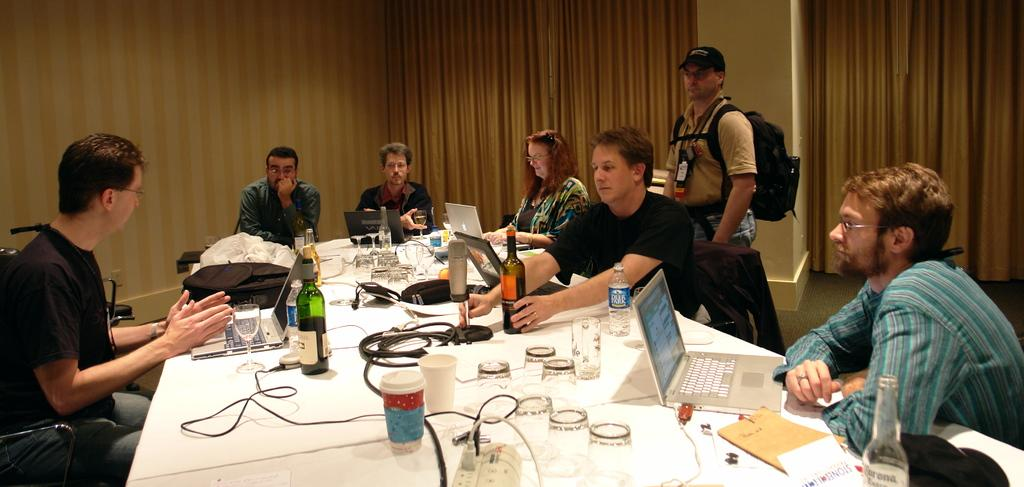What are the people in the image doing while sitting in chairs? The people in the image are operating laptops while sitting in chairs. What objects are present on the table in front of the people? The provided facts do not mention any objects on the table. What type of glasses can be seen in the image? There are bottle glasses present in the image. What is the man standing behind the people wearing? The man standing behind the people is wearing a backpack. Are there any fairies visible in the image? No, there are no fairies present in the image. What historical event is being discussed by the people in the image? The provided facts do not mention any historical event or discussion. 